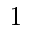<formula> <loc_0><loc_0><loc_500><loc_500>1</formula> 